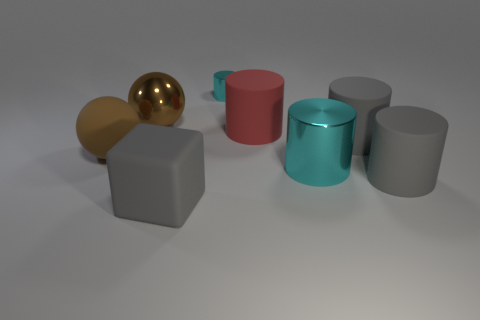Add 2 brown shiny objects. How many objects exist? 10 Subtract all cyan cylinders. How many cylinders are left? 3 Add 1 cylinders. How many cylinders exist? 6 Subtract all cyan cylinders. How many cylinders are left? 3 Subtract 0 blue spheres. How many objects are left? 8 Subtract all spheres. How many objects are left? 6 Subtract 2 spheres. How many spheres are left? 0 Subtract all brown blocks. Subtract all red spheres. How many blocks are left? 1 Subtract all gray spheres. How many gray cylinders are left? 2 Subtract all big matte cubes. Subtract all green cylinders. How many objects are left? 7 